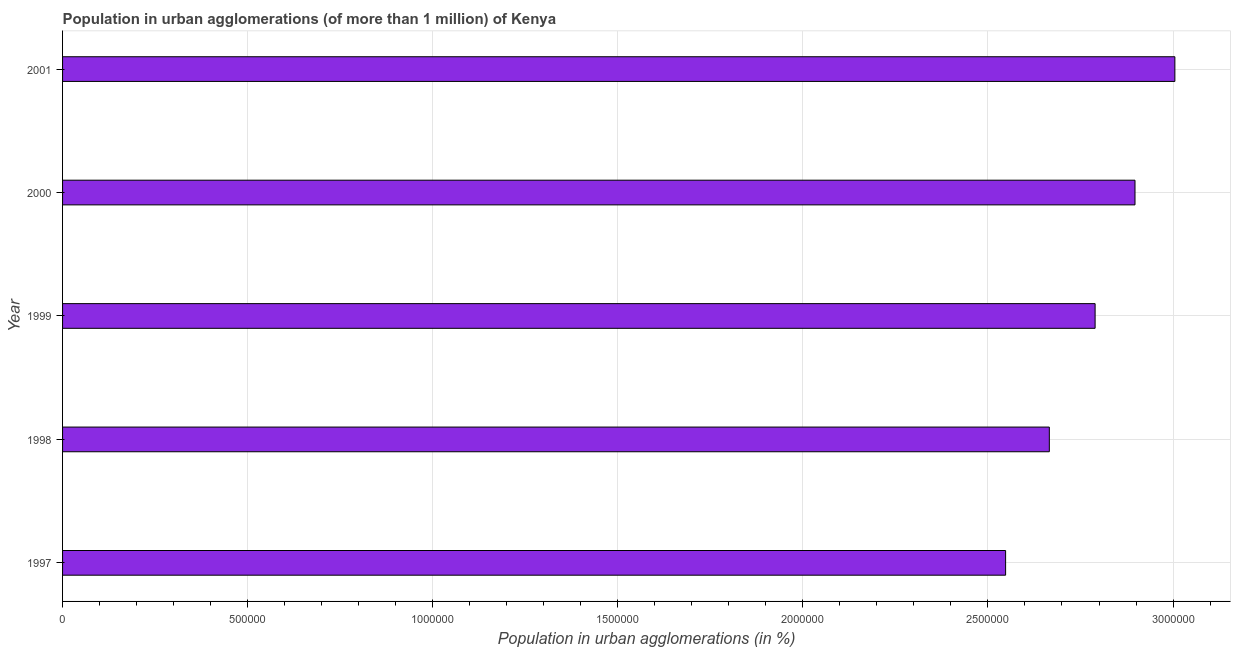What is the title of the graph?
Keep it short and to the point. Population in urban agglomerations (of more than 1 million) of Kenya. What is the label or title of the X-axis?
Make the answer very short. Population in urban agglomerations (in %). What is the population in urban agglomerations in 2000?
Provide a short and direct response. 2.90e+06. Across all years, what is the maximum population in urban agglomerations?
Provide a short and direct response. 3.00e+06. Across all years, what is the minimum population in urban agglomerations?
Provide a succinct answer. 2.55e+06. In which year was the population in urban agglomerations minimum?
Provide a succinct answer. 1997. What is the sum of the population in urban agglomerations?
Provide a short and direct response. 1.39e+07. What is the difference between the population in urban agglomerations in 1999 and 2000?
Provide a short and direct response. -1.08e+05. What is the average population in urban agglomerations per year?
Provide a succinct answer. 2.78e+06. What is the median population in urban agglomerations?
Keep it short and to the point. 2.79e+06. What is the ratio of the population in urban agglomerations in 1998 to that in 2001?
Offer a terse response. 0.89. What is the difference between the highest and the second highest population in urban agglomerations?
Provide a succinct answer. 1.08e+05. Is the sum of the population in urban agglomerations in 1998 and 2000 greater than the maximum population in urban agglomerations across all years?
Your answer should be very brief. Yes. What is the difference between the highest and the lowest population in urban agglomerations?
Provide a succinct answer. 4.57e+05. In how many years, is the population in urban agglomerations greater than the average population in urban agglomerations taken over all years?
Your response must be concise. 3. How many bars are there?
Your response must be concise. 5. Are all the bars in the graph horizontal?
Offer a terse response. Yes. What is the Population in urban agglomerations (in %) in 1997?
Offer a terse response. 2.55e+06. What is the Population in urban agglomerations (in %) of 1998?
Offer a very short reply. 2.67e+06. What is the Population in urban agglomerations (in %) of 1999?
Your response must be concise. 2.79e+06. What is the Population in urban agglomerations (in %) of 2000?
Your response must be concise. 2.90e+06. What is the Population in urban agglomerations (in %) of 2001?
Provide a short and direct response. 3.00e+06. What is the difference between the Population in urban agglomerations (in %) in 1997 and 1998?
Give a very brief answer. -1.18e+05. What is the difference between the Population in urban agglomerations (in %) in 1997 and 1999?
Provide a succinct answer. -2.42e+05. What is the difference between the Population in urban agglomerations (in %) in 1997 and 2000?
Keep it short and to the point. -3.50e+05. What is the difference between the Population in urban agglomerations (in %) in 1997 and 2001?
Keep it short and to the point. -4.57e+05. What is the difference between the Population in urban agglomerations (in %) in 1998 and 1999?
Keep it short and to the point. -1.24e+05. What is the difference between the Population in urban agglomerations (in %) in 1998 and 2000?
Your answer should be very brief. -2.31e+05. What is the difference between the Population in urban agglomerations (in %) in 1998 and 2001?
Ensure brevity in your answer.  -3.39e+05. What is the difference between the Population in urban agglomerations (in %) in 1999 and 2000?
Your answer should be compact. -1.08e+05. What is the difference between the Population in urban agglomerations (in %) in 1999 and 2001?
Your answer should be very brief. -2.15e+05. What is the difference between the Population in urban agglomerations (in %) in 2000 and 2001?
Offer a very short reply. -1.08e+05. What is the ratio of the Population in urban agglomerations (in %) in 1997 to that in 1998?
Ensure brevity in your answer.  0.96. What is the ratio of the Population in urban agglomerations (in %) in 1997 to that in 2000?
Your answer should be compact. 0.88. What is the ratio of the Population in urban agglomerations (in %) in 1997 to that in 2001?
Offer a very short reply. 0.85. What is the ratio of the Population in urban agglomerations (in %) in 1998 to that in 1999?
Give a very brief answer. 0.96. What is the ratio of the Population in urban agglomerations (in %) in 1998 to that in 2000?
Ensure brevity in your answer.  0.92. What is the ratio of the Population in urban agglomerations (in %) in 1998 to that in 2001?
Keep it short and to the point. 0.89. What is the ratio of the Population in urban agglomerations (in %) in 1999 to that in 2001?
Your response must be concise. 0.93. 